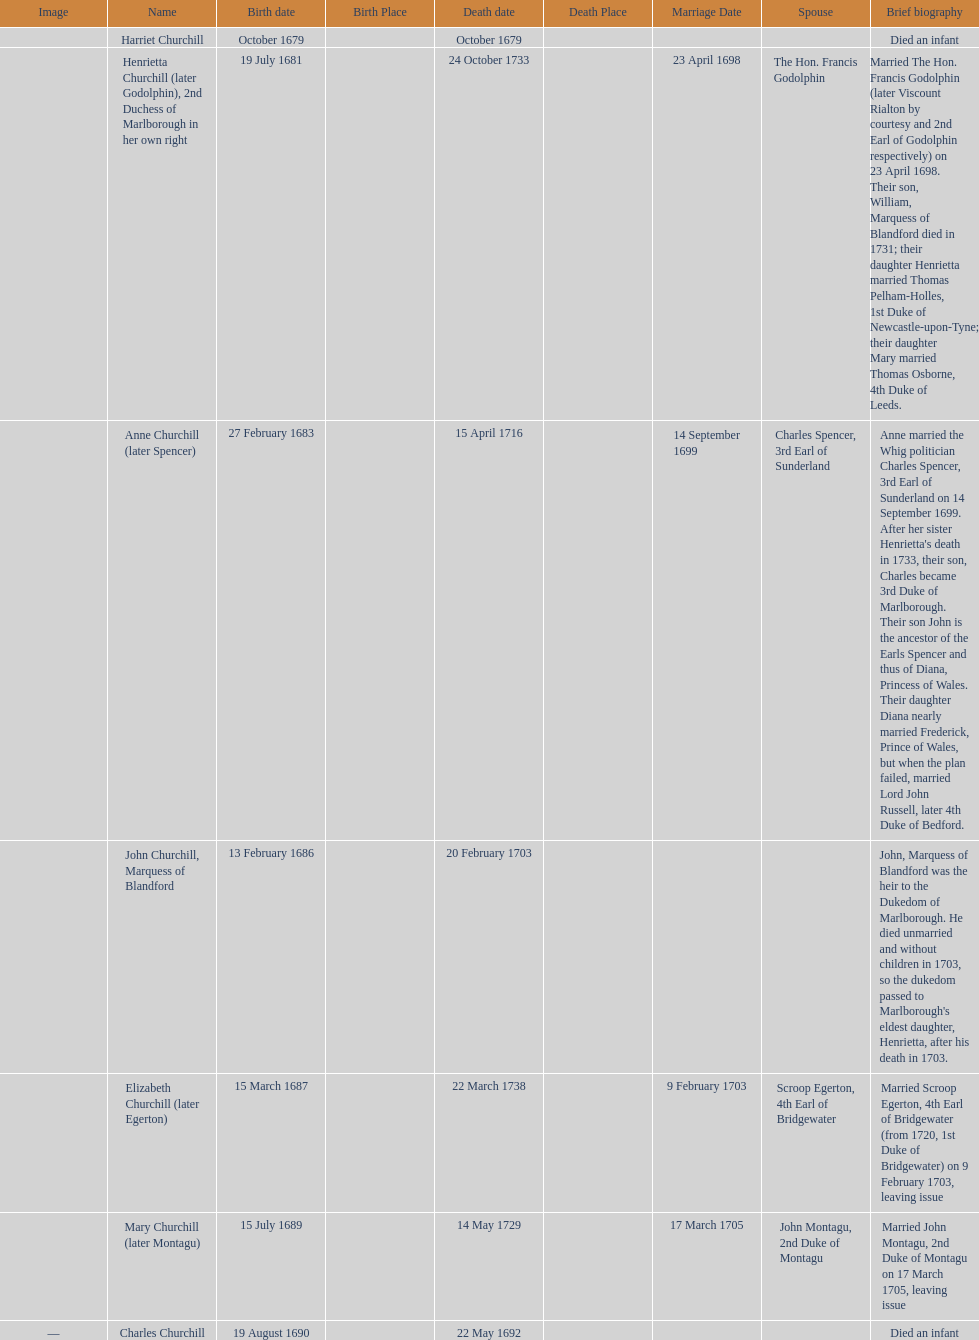What is the number of children sarah churchill had? 7. 